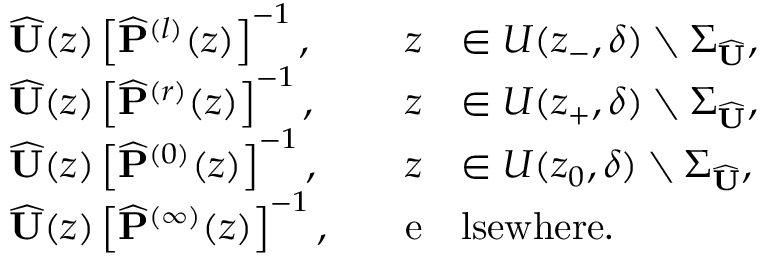<formula> <loc_0><loc_0><loc_500><loc_500>\begin{array} { r l r l } & { \widehat { U } ( z ) \left [ \widehat { P } ^ { ( l ) } ( z ) \right ] ^ { - 1 } , \quad } & { z } & { \in U ( z _ { - } , \delta ) \ \Sigma _ { \widehat { U } } , } \\ & { \widehat { U } ( z ) \left [ \widehat { P } ^ { ( r ) } ( z ) \right ] ^ { - 1 } , \quad } & { z } & { \in U ( z _ { + } , \delta ) \ \Sigma _ { \widehat { U } } , } \\ & { \widehat { U } ( z ) \left [ \widehat { P } ^ { ( 0 ) } ( z ) \right ] ^ { - 1 } , \quad } & { z } & { \in U ( z _ { 0 } , \delta ) \ \Sigma _ { \widehat { U } } , } \\ & { \widehat { U } ( z ) \left [ \widehat { P } ^ { ( \infty ) } ( z ) \right ] ^ { - 1 } , \quad } & { e } & { l s e w h e r e . } \end{array}</formula> 